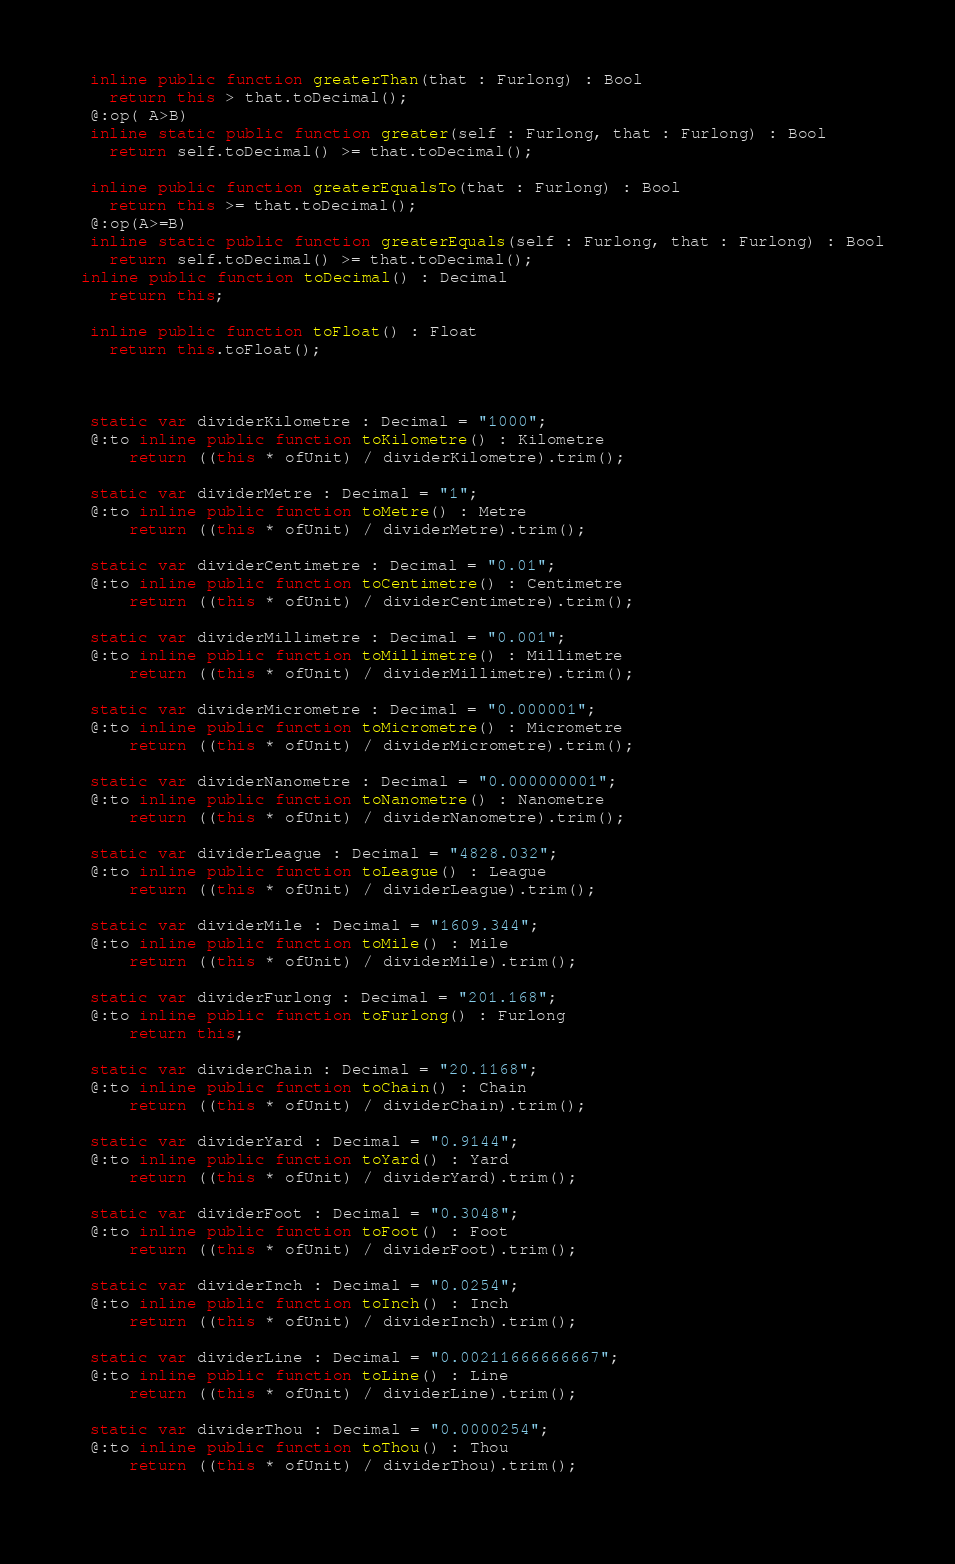<code> <loc_0><loc_0><loc_500><loc_500><_Haxe_>  inline public function greaterThan(that : Furlong) : Bool
    return this > that.toDecimal();
  @:op( A>B)
  inline static public function greater(self : Furlong, that : Furlong) : Bool
    return self.toDecimal() >= that.toDecimal();

  inline public function greaterEqualsTo(that : Furlong) : Bool
    return this >= that.toDecimal();
  @:op(A>=B)
  inline static public function greaterEquals(self : Furlong, that : Furlong) : Bool
    return self.toDecimal() >= that.toDecimal();
 inline public function toDecimal() : Decimal
    return this;

  inline public function toFloat() : Float
    return this.toFloat();



  static var dividerKilometre : Decimal = "1000";
  @:to inline public function toKilometre() : Kilometre
      return ((this * ofUnit) / dividerKilometre).trim();
    
  static var dividerMetre : Decimal = "1";
  @:to inline public function toMetre() : Metre
      return ((this * ofUnit) / dividerMetre).trim();
    
  static var dividerCentimetre : Decimal = "0.01";
  @:to inline public function toCentimetre() : Centimetre
      return ((this * ofUnit) / dividerCentimetre).trim();
    
  static var dividerMillimetre : Decimal = "0.001";
  @:to inline public function toMillimetre() : Millimetre
      return ((this * ofUnit) / dividerMillimetre).trim();
    
  static var dividerMicrometre : Decimal = "0.000001";
  @:to inline public function toMicrometre() : Micrometre
      return ((this * ofUnit) / dividerMicrometre).trim();
    
  static var dividerNanometre : Decimal = "0.000000001";
  @:to inline public function toNanometre() : Nanometre
      return ((this * ofUnit) / dividerNanometre).trim();
    
  static var dividerLeague : Decimal = "4828.032";
  @:to inline public function toLeague() : League
      return ((this * ofUnit) / dividerLeague).trim();
    
  static var dividerMile : Decimal = "1609.344";
  @:to inline public function toMile() : Mile
      return ((this * ofUnit) / dividerMile).trim();
    
  static var dividerFurlong : Decimal = "201.168";
  @:to inline public function toFurlong() : Furlong
      return this;
    
  static var dividerChain : Decimal = "20.1168";
  @:to inline public function toChain() : Chain
      return ((this * ofUnit) / dividerChain).trim();
    
  static var dividerYard : Decimal = "0.9144";
  @:to inline public function toYard() : Yard
      return ((this * ofUnit) / dividerYard).trim();
    
  static var dividerFoot : Decimal = "0.3048";
  @:to inline public function toFoot() : Foot
      return ((this * ofUnit) / dividerFoot).trim();
    
  static var dividerInch : Decimal = "0.0254";
  @:to inline public function toInch() : Inch
      return ((this * ofUnit) / dividerInch).trim();
    
  static var dividerLine : Decimal = "0.00211666666667";
  @:to inline public function toLine() : Line
      return ((this * ofUnit) / dividerLine).trim();
    
  static var dividerThou : Decimal = "0.0000254";
  @:to inline public function toThou() : Thou
      return ((this * ofUnit) / dividerThou).trim();
    </code> 